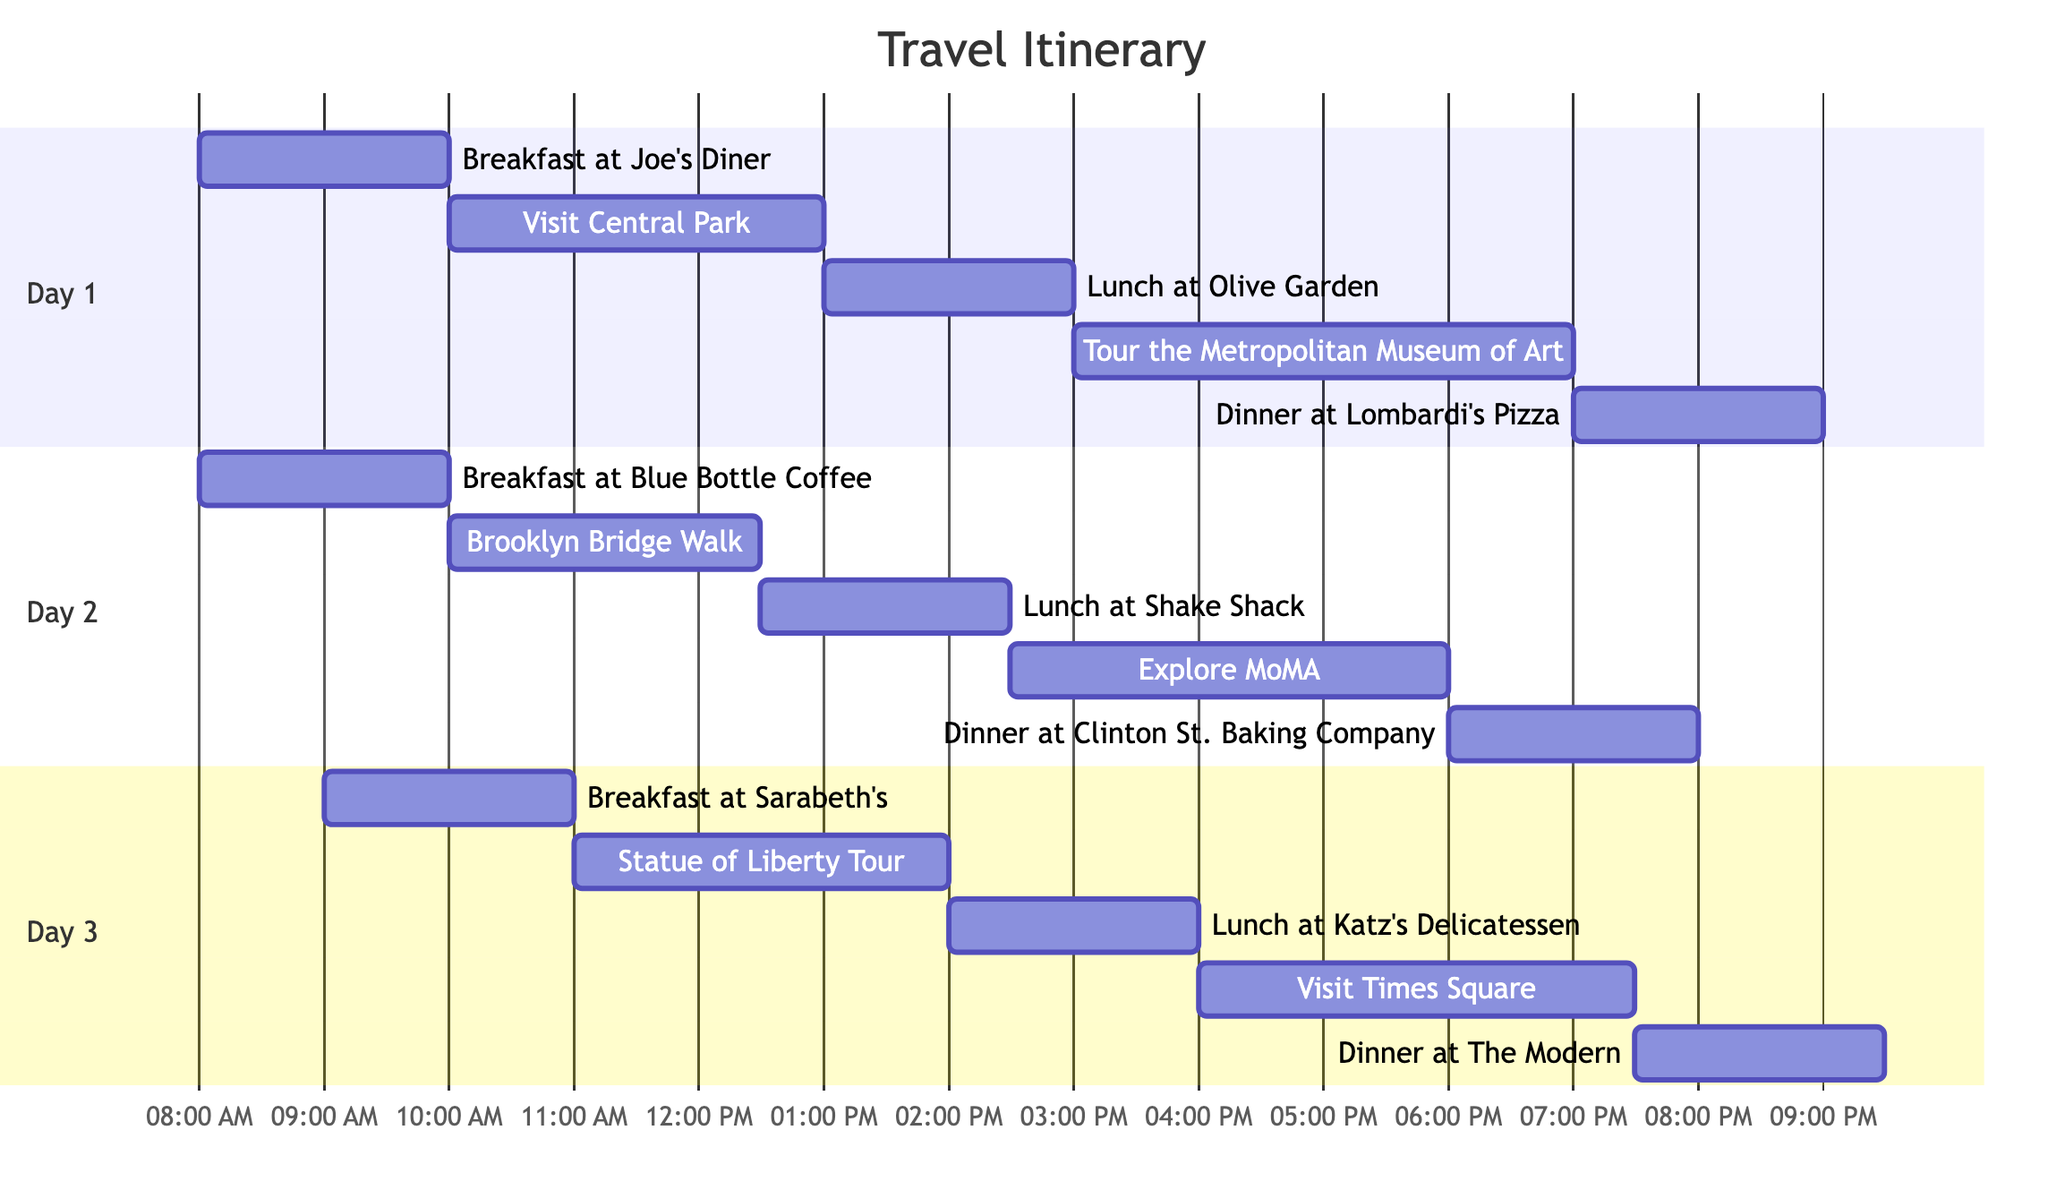What time does Breakfast at Joe's Diner start? The diagram shows the starting time for Breakfast at Joe's Diner listed under Day 1. It indicates that it starts at 08:00.
Answer: 08:00 How long is the Brooklyn Bridge Walk? The diagram indicates that the Brooklyn Bridge Walk lasts for 2.5 hours, as listed under Day 2.
Answer: 2.5h What is scheduled immediately after lunch at Shake Shack? After Lunch at Shake Shack, the next activity shown on Day 2 is Explore MoMA, which starts at 14:30.
Answer: Explore MoMA Which dinner is scheduled last in the itinerary? Looking at Day 3, the last dinner scheduled is at The Modern, starting at 19:30.
Answer: The Modern How many activities are planned for Day 1? Day 1 lists five activities in total: Breakfast at Joe's Diner, Visit Central Park, Lunch at Olive Garden, Tour the Metropolitan Museum of Art, and Dinner at Lombardi's Pizza.
Answer: 5 On Day 3, what is the duration of the Statue of Liberty Tour? The duration for the Statue of Liberty Tour is indicated as lasting 3 hours, according to the schedule in Day 3.
Answer: 3h Which day has the earliest breakfast? By checking the breakfast times, we see that Day 1 has the earliest breakfast at 08:00, compared to the other days.
Answer: Day 1 What meal is associated with 18:00 on Day 2? The diagram specifies that Dinner at Clinton St. Baking Company is scheduled for 18:00 on Day 2.
Answer: Dinner at Clinton St. Baking Company What activity starts at 16:00 on Day 3? According to Day 3's schedule, the activity lined up for 16:00 is Visit Times Square.
Answer: Visit Times Square 